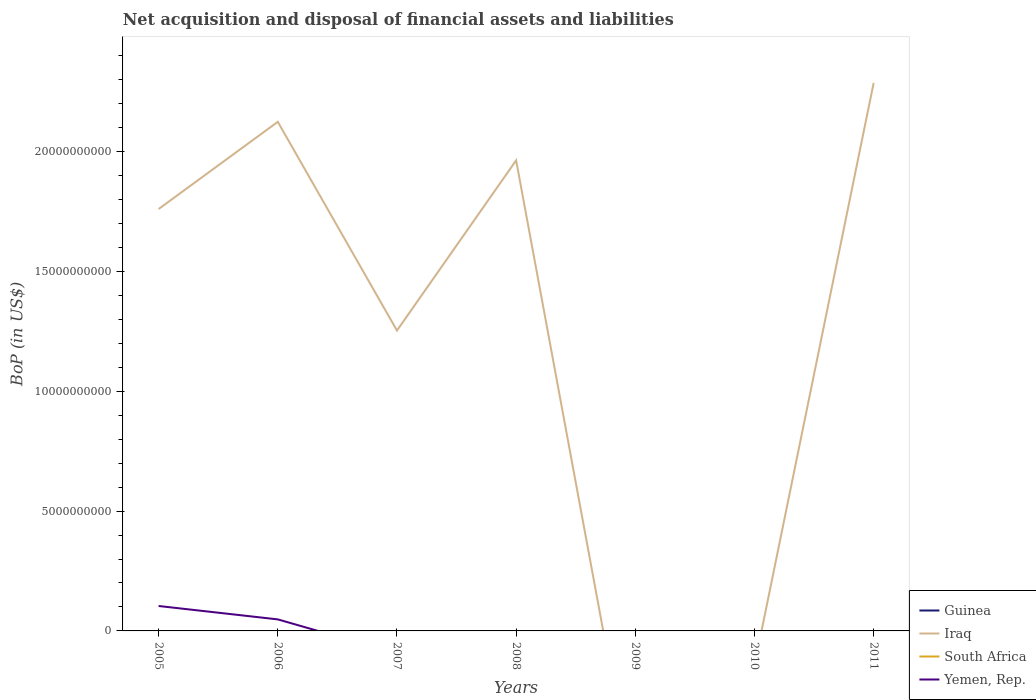Does the line corresponding to Guinea intersect with the line corresponding to Iraq?
Ensure brevity in your answer.  Yes. Across all years, what is the maximum Balance of Payments in Iraq?
Provide a succinct answer. 0. What is the total Balance of Payments in Iraq in the graph?
Provide a short and direct response. -2.03e+09. What is the difference between the highest and the second highest Balance of Payments in Iraq?
Your answer should be compact. 2.29e+1. Is the Balance of Payments in Yemen, Rep. strictly greater than the Balance of Payments in South Africa over the years?
Your answer should be compact. No. How many lines are there?
Your answer should be very brief. 2. How many years are there in the graph?
Make the answer very short. 7. What is the difference between two consecutive major ticks on the Y-axis?
Offer a terse response. 5.00e+09. Are the values on the major ticks of Y-axis written in scientific E-notation?
Offer a very short reply. No. Does the graph contain any zero values?
Provide a short and direct response. Yes. What is the title of the graph?
Ensure brevity in your answer.  Net acquisition and disposal of financial assets and liabilities. Does "Saudi Arabia" appear as one of the legend labels in the graph?
Provide a short and direct response. No. What is the label or title of the Y-axis?
Provide a succinct answer. BoP (in US$). What is the BoP (in US$) of Iraq in 2005?
Your response must be concise. 1.76e+1. What is the BoP (in US$) in Yemen, Rep. in 2005?
Your answer should be compact. 1.04e+09. What is the BoP (in US$) of Iraq in 2006?
Your response must be concise. 2.12e+1. What is the BoP (in US$) in South Africa in 2006?
Give a very brief answer. 0. What is the BoP (in US$) of Yemen, Rep. in 2006?
Provide a succinct answer. 4.81e+08. What is the BoP (in US$) of Iraq in 2007?
Provide a short and direct response. 1.25e+1. What is the BoP (in US$) of South Africa in 2007?
Provide a succinct answer. 0. What is the BoP (in US$) of Guinea in 2008?
Your answer should be very brief. 0. What is the BoP (in US$) in Iraq in 2008?
Your response must be concise. 1.96e+1. What is the BoP (in US$) in South Africa in 2008?
Provide a succinct answer. 0. What is the BoP (in US$) in South Africa in 2009?
Make the answer very short. 0. What is the BoP (in US$) in Yemen, Rep. in 2009?
Give a very brief answer. 0. What is the BoP (in US$) of Iraq in 2010?
Make the answer very short. 0. What is the BoP (in US$) in Yemen, Rep. in 2010?
Your answer should be compact. 0. What is the BoP (in US$) of Guinea in 2011?
Make the answer very short. 0. What is the BoP (in US$) of Iraq in 2011?
Your answer should be very brief. 2.29e+1. Across all years, what is the maximum BoP (in US$) in Iraq?
Offer a terse response. 2.29e+1. Across all years, what is the maximum BoP (in US$) in Yemen, Rep.?
Ensure brevity in your answer.  1.04e+09. Across all years, what is the minimum BoP (in US$) in Iraq?
Your response must be concise. 0. Across all years, what is the minimum BoP (in US$) of Yemen, Rep.?
Offer a terse response. 0. What is the total BoP (in US$) of Guinea in the graph?
Offer a very short reply. 0. What is the total BoP (in US$) of Iraq in the graph?
Provide a succinct answer. 9.39e+1. What is the total BoP (in US$) of South Africa in the graph?
Offer a very short reply. 0. What is the total BoP (in US$) in Yemen, Rep. in the graph?
Provide a succinct answer. 1.52e+09. What is the difference between the BoP (in US$) in Iraq in 2005 and that in 2006?
Your answer should be compact. -3.64e+09. What is the difference between the BoP (in US$) of Yemen, Rep. in 2005 and that in 2006?
Make the answer very short. 5.59e+08. What is the difference between the BoP (in US$) of Iraq in 2005 and that in 2007?
Make the answer very short. 5.07e+09. What is the difference between the BoP (in US$) in Iraq in 2005 and that in 2008?
Keep it short and to the point. -2.03e+09. What is the difference between the BoP (in US$) of Iraq in 2005 and that in 2011?
Provide a short and direct response. -5.26e+09. What is the difference between the BoP (in US$) in Iraq in 2006 and that in 2007?
Make the answer very short. 8.71e+09. What is the difference between the BoP (in US$) of Iraq in 2006 and that in 2008?
Keep it short and to the point. 1.61e+09. What is the difference between the BoP (in US$) of Iraq in 2006 and that in 2011?
Ensure brevity in your answer.  -1.62e+09. What is the difference between the BoP (in US$) in Iraq in 2007 and that in 2008?
Offer a very short reply. -7.10e+09. What is the difference between the BoP (in US$) in Iraq in 2007 and that in 2011?
Provide a short and direct response. -1.03e+1. What is the difference between the BoP (in US$) in Iraq in 2008 and that in 2011?
Give a very brief answer. -3.23e+09. What is the difference between the BoP (in US$) in Iraq in 2005 and the BoP (in US$) in Yemen, Rep. in 2006?
Make the answer very short. 1.71e+1. What is the average BoP (in US$) of Guinea per year?
Your answer should be very brief. 0. What is the average BoP (in US$) in Iraq per year?
Offer a very short reply. 1.34e+1. What is the average BoP (in US$) in Yemen, Rep. per year?
Give a very brief answer. 2.17e+08. In the year 2005, what is the difference between the BoP (in US$) of Iraq and BoP (in US$) of Yemen, Rep.?
Offer a very short reply. 1.66e+1. In the year 2006, what is the difference between the BoP (in US$) of Iraq and BoP (in US$) of Yemen, Rep.?
Ensure brevity in your answer.  2.08e+1. What is the ratio of the BoP (in US$) of Iraq in 2005 to that in 2006?
Give a very brief answer. 0.83. What is the ratio of the BoP (in US$) of Yemen, Rep. in 2005 to that in 2006?
Keep it short and to the point. 2.16. What is the ratio of the BoP (in US$) in Iraq in 2005 to that in 2007?
Ensure brevity in your answer.  1.4. What is the ratio of the BoP (in US$) in Iraq in 2005 to that in 2008?
Keep it short and to the point. 0.9. What is the ratio of the BoP (in US$) in Iraq in 2005 to that in 2011?
Ensure brevity in your answer.  0.77. What is the ratio of the BoP (in US$) in Iraq in 2006 to that in 2007?
Offer a very short reply. 1.69. What is the ratio of the BoP (in US$) of Iraq in 2006 to that in 2008?
Give a very brief answer. 1.08. What is the ratio of the BoP (in US$) in Iraq in 2006 to that in 2011?
Offer a very short reply. 0.93. What is the ratio of the BoP (in US$) in Iraq in 2007 to that in 2008?
Provide a succinct answer. 0.64. What is the ratio of the BoP (in US$) in Iraq in 2007 to that in 2011?
Offer a terse response. 0.55. What is the ratio of the BoP (in US$) of Iraq in 2008 to that in 2011?
Ensure brevity in your answer.  0.86. What is the difference between the highest and the second highest BoP (in US$) in Iraq?
Give a very brief answer. 1.62e+09. What is the difference between the highest and the lowest BoP (in US$) of Iraq?
Your answer should be very brief. 2.29e+1. What is the difference between the highest and the lowest BoP (in US$) of Yemen, Rep.?
Offer a terse response. 1.04e+09. 